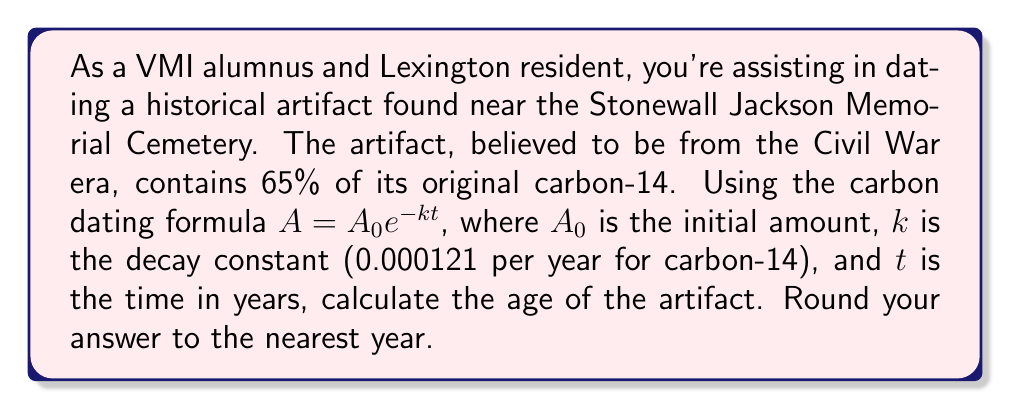Can you solve this math problem? Let's approach this step-by-step:

1) We're using the formula $A = A_0 e^{-kt}$, where:
   $A$ is the current amount (65% of original)
   $A_0$ is the initial amount (100%)
   $k$ is the decay constant (0.000121 per year)
   $t$ is the time in years (what we're solving for)

2) We can rewrite the equation as a fraction:
   $\frac{A}{A_0} = e^{-kt}$

3) Substituting our known values:
   $\frac{65}{100} = e^{-0.000121t}$

4) Take the natural log of both sides:
   $\ln(\frac{65}{100}) = \ln(e^{-0.000121t})$

5) Simplify the right side:
   $\ln(0.65) = -0.000121t$

6) Solve for $t$:
   $t = \frac{\ln(0.65)}{-0.000121}$

7) Calculate:
   $t = \frac{-0.4308}{-0.000121} \approx 3560.33$ years

8) Rounding to the nearest year:
   $t \approx 3560$ years
Answer: The artifact is approximately 3560 years old. 